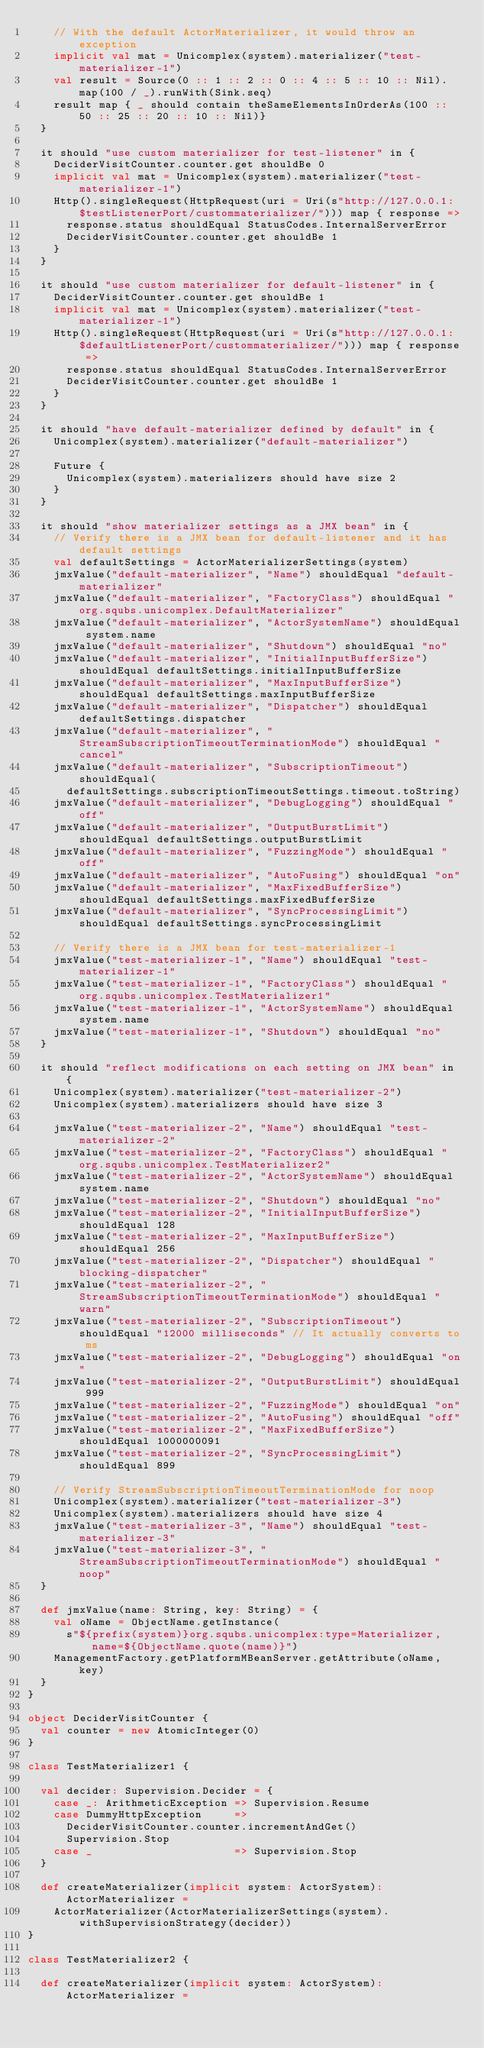Convert code to text. <code><loc_0><loc_0><loc_500><loc_500><_Scala_>    // With the default ActorMaterializer, it would throw an exception
    implicit val mat = Unicomplex(system).materializer("test-materializer-1")
    val result = Source(0 :: 1 :: 2 :: 0 :: 4 :: 5 :: 10 :: Nil).map(100 / _).runWith(Sink.seq)
    result map { _ should contain theSameElementsInOrderAs(100 :: 50 :: 25 :: 20 :: 10 :: Nil)}
  }

  it should "use custom materializer for test-listener" in {
    DeciderVisitCounter.counter.get shouldBe 0
    implicit val mat = Unicomplex(system).materializer("test-materializer-1")
    Http().singleRequest(HttpRequest(uri = Uri(s"http://127.0.0.1:$testListenerPort/custommaterializer/"))) map { response =>
      response.status shouldEqual StatusCodes.InternalServerError
      DeciderVisitCounter.counter.get shouldBe 1
    }
  }

  it should "use custom materializer for default-listener" in {
    DeciderVisitCounter.counter.get shouldBe 1
    implicit val mat = Unicomplex(system).materializer("test-materializer-1")
    Http().singleRequest(HttpRequest(uri = Uri(s"http://127.0.0.1:$defaultListenerPort/custommaterializer/"))) map { response =>
      response.status shouldEqual StatusCodes.InternalServerError
      DeciderVisitCounter.counter.get shouldBe 1
    }
  }

  it should "have default-materializer defined by default" in {
    Unicomplex(system).materializer("default-materializer")

    Future {
      Unicomplex(system).materializers should have size 2
    }
  }

  it should "show materializer settings as a JMX bean" in {
    // Verify there is a JMX bean for default-listener and it has default settings
    val defaultSettings = ActorMaterializerSettings(system)
    jmxValue("default-materializer", "Name") shouldEqual "default-materializer"
    jmxValue("default-materializer", "FactoryClass") shouldEqual "org.squbs.unicomplex.DefaultMaterializer"
    jmxValue("default-materializer", "ActorSystemName") shouldEqual system.name
    jmxValue("default-materializer", "Shutdown") shouldEqual "no"
    jmxValue("default-materializer", "InitialInputBufferSize") shouldEqual defaultSettings.initialInputBufferSize
    jmxValue("default-materializer", "MaxInputBufferSize") shouldEqual defaultSettings.maxInputBufferSize
    jmxValue("default-materializer", "Dispatcher") shouldEqual defaultSettings.dispatcher
    jmxValue("default-materializer", "StreamSubscriptionTimeoutTerminationMode") shouldEqual "cancel"
    jmxValue("default-materializer", "SubscriptionTimeout") shouldEqual(
      defaultSettings.subscriptionTimeoutSettings.timeout.toString)
    jmxValue("default-materializer", "DebugLogging") shouldEqual "off"
    jmxValue("default-materializer", "OutputBurstLimit") shouldEqual defaultSettings.outputBurstLimit
    jmxValue("default-materializer", "FuzzingMode") shouldEqual "off"
    jmxValue("default-materializer", "AutoFusing") shouldEqual "on"
    jmxValue("default-materializer", "MaxFixedBufferSize") shouldEqual defaultSettings.maxFixedBufferSize
    jmxValue("default-materializer", "SyncProcessingLimit") shouldEqual defaultSettings.syncProcessingLimit

    // Verify there is a JMX bean for test-materializer-1
    jmxValue("test-materializer-1", "Name") shouldEqual "test-materializer-1"
    jmxValue("test-materializer-1", "FactoryClass") shouldEqual "org.squbs.unicomplex.TestMaterializer1"
    jmxValue("test-materializer-1", "ActorSystemName") shouldEqual system.name
    jmxValue("test-materializer-1", "Shutdown") shouldEqual "no"
  }

  it should "reflect modifications on each setting on JMX bean" in {
    Unicomplex(system).materializer("test-materializer-2")
    Unicomplex(system).materializers should have size 3

    jmxValue("test-materializer-2", "Name") shouldEqual "test-materializer-2"
    jmxValue("test-materializer-2", "FactoryClass") shouldEqual "org.squbs.unicomplex.TestMaterializer2"
    jmxValue("test-materializer-2", "ActorSystemName") shouldEqual system.name
    jmxValue("test-materializer-2", "Shutdown") shouldEqual "no"
    jmxValue("test-materializer-2", "InitialInputBufferSize") shouldEqual 128
    jmxValue("test-materializer-2", "MaxInputBufferSize") shouldEqual 256
    jmxValue("test-materializer-2", "Dispatcher") shouldEqual "blocking-dispatcher"
    jmxValue("test-materializer-2", "StreamSubscriptionTimeoutTerminationMode") shouldEqual "warn"
    jmxValue("test-materializer-2", "SubscriptionTimeout") shouldEqual "12000 milliseconds" // It actually converts to ms
    jmxValue("test-materializer-2", "DebugLogging") shouldEqual "on"
    jmxValue("test-materializer-2", "OutputBurstLimit") shouldEqual 999
    jmxValue("test-materializer-2", "FuzzingMode") shouldEqual "on"
    jmxValue("test-materializer-2", "AutoFusing") shouldEqual "off"
    jmxValue("test-materializer-2", "MaxFixedBufferSize") shouldEqual 1000000091
    jmxValue("test-materializer-2", "SyncProcessingLimit") shouldEqual 899

    // Verify StreamSubscriptionTimeoutTerminationMode for noop
    Unicomplex(system).materializer("test-materializer-3")
    Unicomplex(system).materializers should have size 4
    jmxValue("test-materializer-3", "Name") shouldEqual "test-materializer-3"
    jmxValue("test-materializer-3", "StreamSubscriptionTimeoutTerminationMode") shouldEqual "noop"
  }

  def jmxValue(name: String, key: String) = {
    val oName = ObjectName.getInstance(
      s"${prefix(system)}org.squbs.unicomplex:type=Materializer,name=${ObjectName.quote(name)}")
    ManagementFactory.getPlatformMBeanServer.getAttribute(oName, key)
  }
}

object DeciderVisitCounter {
  val counter = new AtomicInteger(0)
}

class TestMaterializer1 {

  val decider: Supervision.Decider = {
    case _: ArithmeticException => Supervision.Resume
    case DummyHttpException     =>
      DeciderVisitCounter.counter.incrementAndGet()
      Supervision.Stop
    case _                      => Supervision.Stop
  }

  def createMaterializer(implicit system: ActorSystem): ActorMaterializer =
    ActorMaterializer(ActorMaterializerSettings(system).withSupervisionStrategy(decider))
}

class TestMaterializer2 {

  def createMaterializer(implicit system: ActorSystem): ActorMaterializer =</code> 